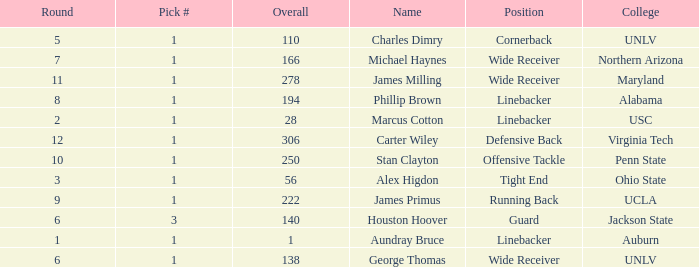In what Round was George Thomas Picked? 6.0. 